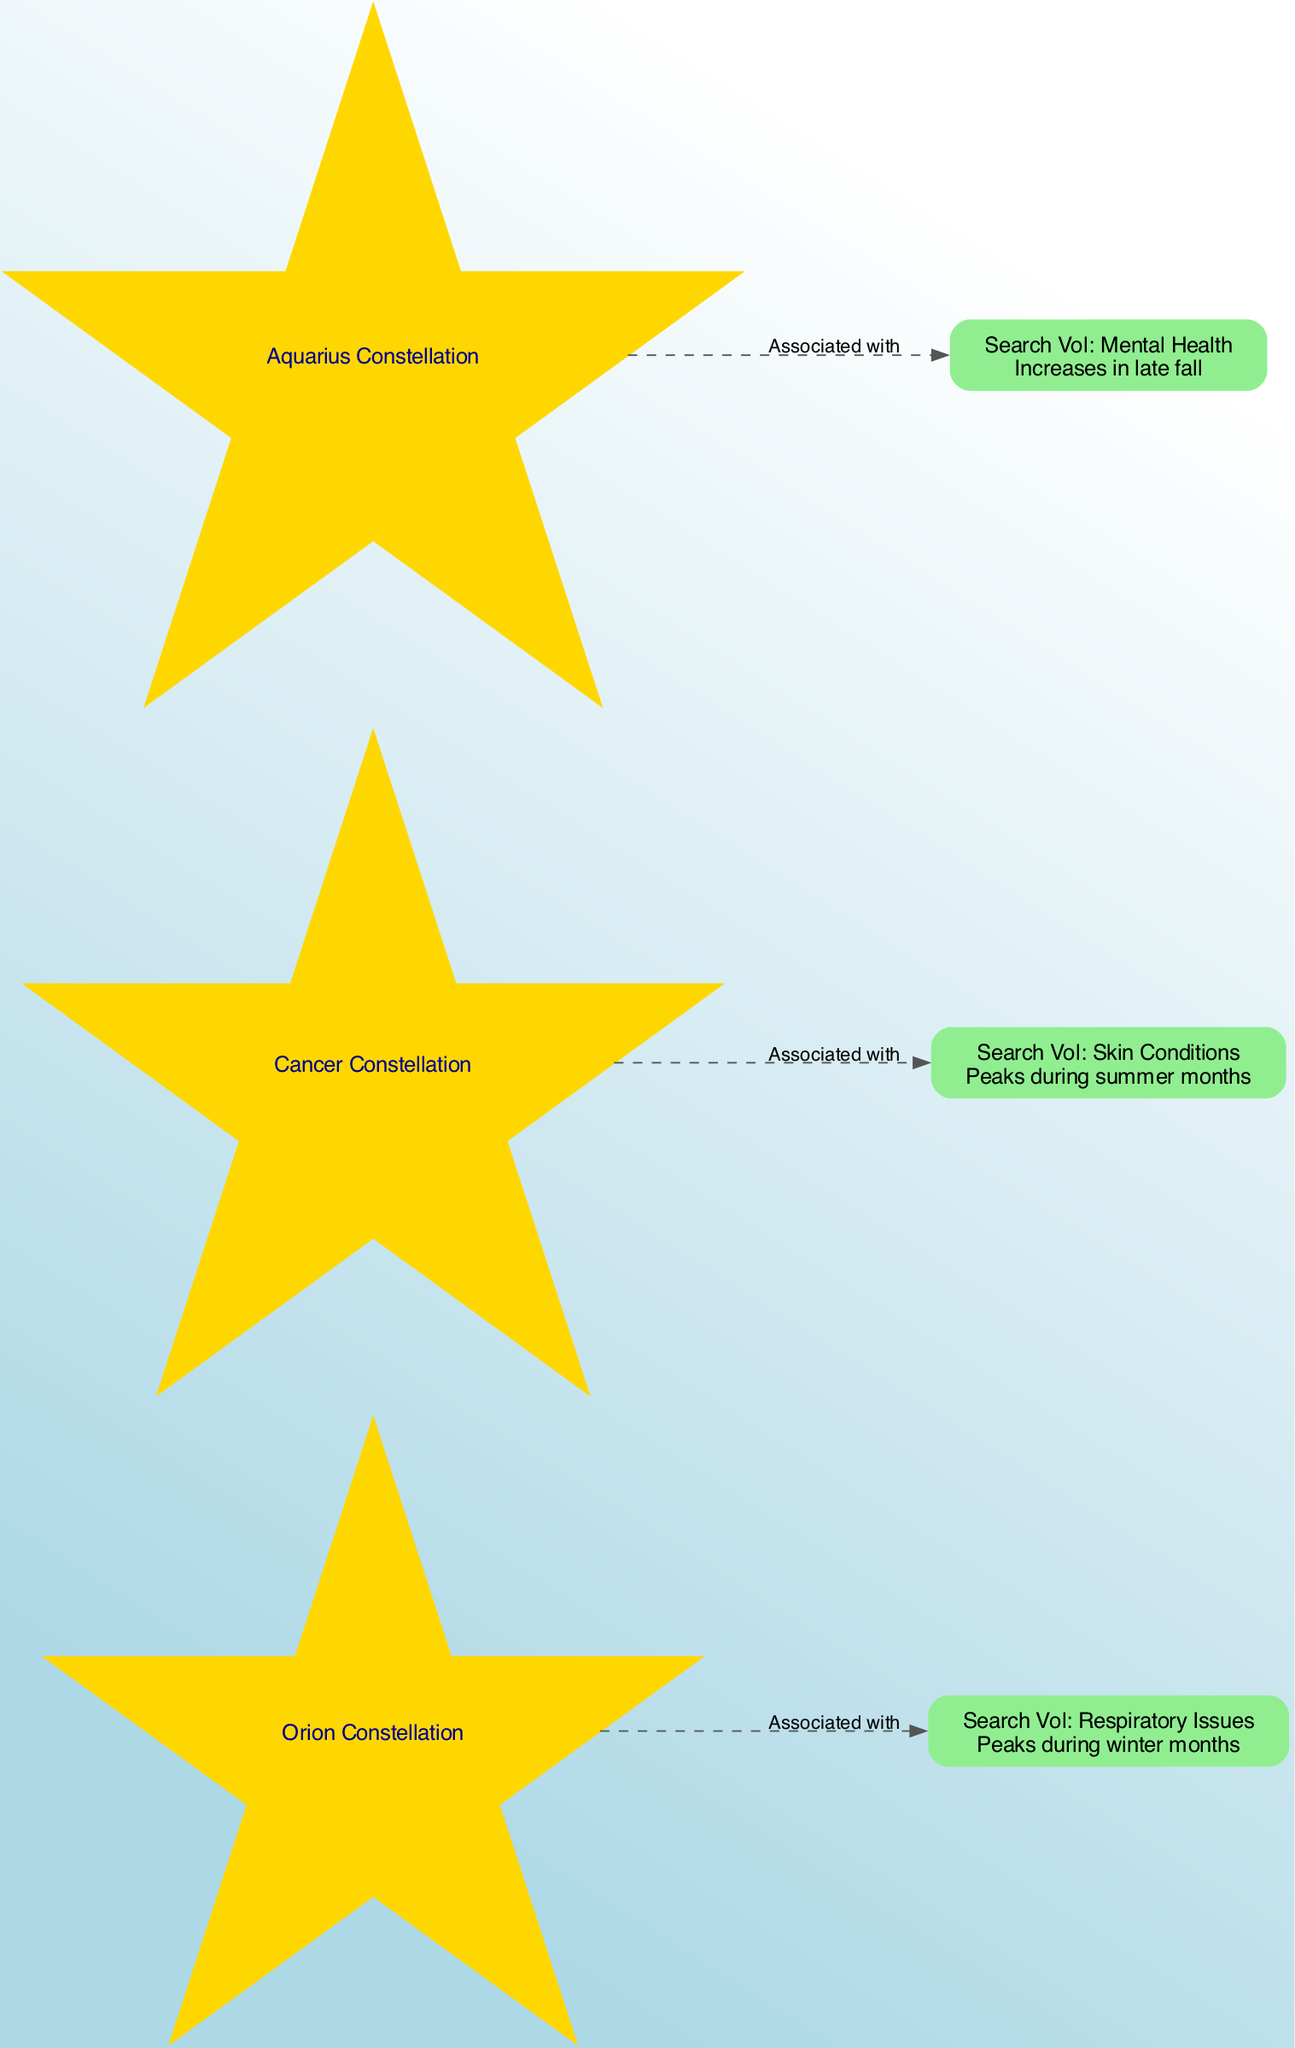What is the main association of the Orion Constellation? The Orion Constellation is associated with "Respiratory Conditions," as noted in its description and linked edge in the diagram.
Answer: Respiratory Conditions During which season does the Search Volume for Skin Conditions peak? The diagram indicates that the Search Volume for Skin Conditions peaks during summer months, as linked to the Cancer Constellation.
Answer: Summer months How many edges are present in the diagram? By counting the edges that connect the constellations to their associated search volumes, we find there are three edges depicted in the diagram.
Answer: 3 What is the link between Aquarius and mental health? Aquarius is associated with mental health queries, as shown by the edge connecting the Aquarius Constellation to the Search Volume for Mental Health.
Answer: Mental health queries What type of health issues are associated with the Cancer Constellation? The Cancer Constellation is linked to "Skin Conditions," as reflected in the relationship depicted in the diagram.
Answer: Skin Conditions Which constellation is linked to respiratory issues? The diagram shows that the Orion Constellation is linked to respiratory issues through its direct connection with the corresponding search volume.
Answer: Orion In what months does the Search Volume for Mental Health increase? The diagram specifies that the Search Volume for Mental Health increases in late fall, highlighted in the description related to the Aquarius Constellation.
Answer: Late fall What color is used to represent the constellations in the diagram? The constellations are visually represented with a gold color, as indicated for their node styling in the diagram.
Answer: Gold What type of conditions does the Orion Constellation imply health issues for? The Orion Constellation implies health issues primarily for "Respiratory Conditions," as described in its description.
Answer: Respiratory Conditions 